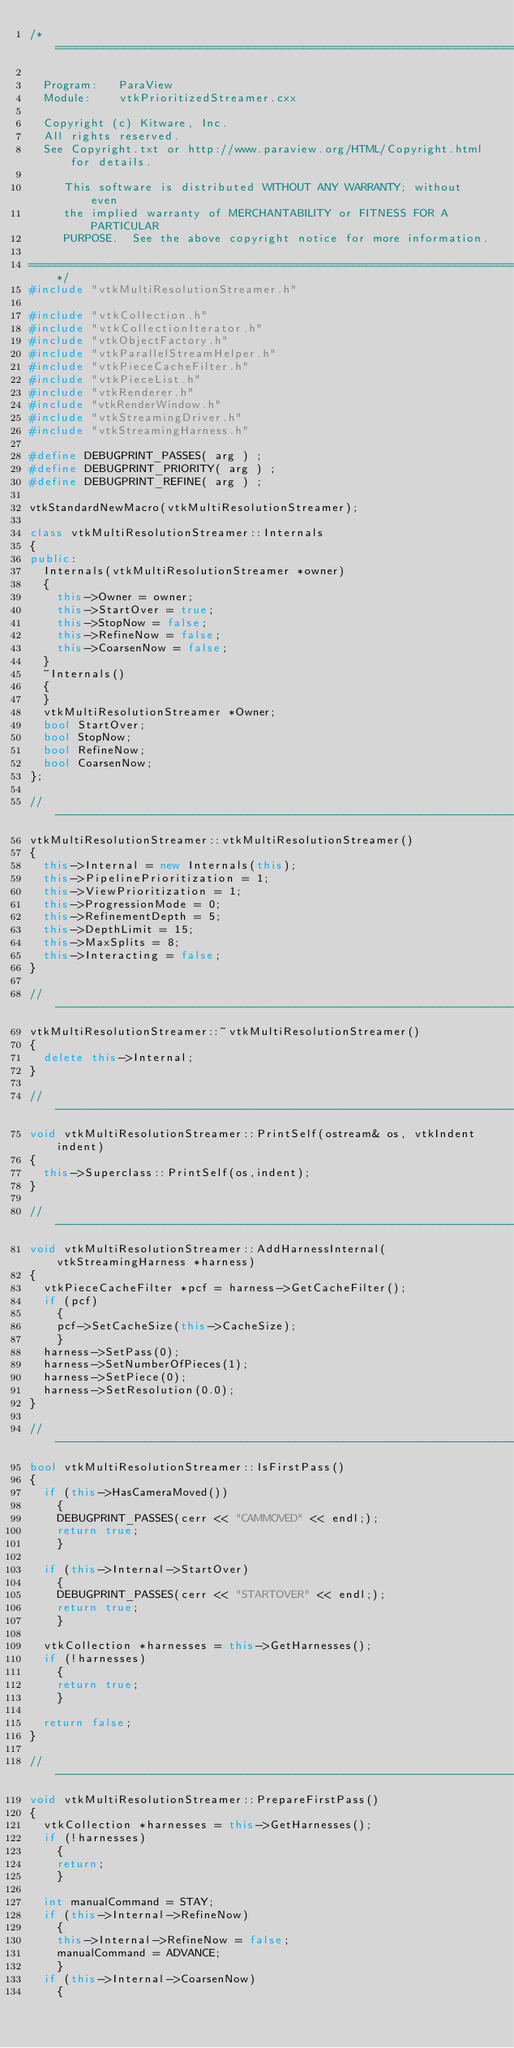<code> <loc_0><loc_0><loc_500><loc_500><_C++_>/*=========================================================================

  Program:   ParaView
  Module:    vtkPrioritizedStreamer.cxx

  Copyright (c) Kitware, Inc.
  All rights reserved.
  See Copyright.txt or http://www.paraview.org/HTML/Copyright.html for details.

     This software is distributed WITHOUT ANY WARRANTY; without even
     the implied warranty of MERCHANTABILITY or FITNESS FOR A PARTICULAR
     PURPOSE.  See the above copyright notice for more information.

=========================================================================*/
#include "vtkMultiResolutionStreamer.h"

#include "vtkCollection.h"
#include "vtkCollectionIterator.h"
#include "vtkObjectFactory.h"
#include "vtkParallelStreamHelper.h"
#include "vtkPieceCacheFilter.h"
#include "vtkPieceList.h"
#include "vtkRenderer.h"
#include "vtkRenderWindow.h"
#include "vtkStreamingDriver.h"
#include "vtkStreamingHarness.h"

#define DEBUGPRINT_PASSES( arg ) ;
#define DEBUGPRINT_PRIORITY( arg ) ;
#define DEBUGPRINT_REFINE( arg ) ;

vtkStandardNewMacro(vtkMultiResolutionStreamer);

class vtkMultiResolutionStreamer::Internals
{
public:
  Internals(vtkMultiResolutionStreamer *owner)
  {
    this->Owner = owner;
    this->StartOver = true;
    this->StopNow = false;
    this->RefineNow = false;
    this->CoarsenNow = false;
  }
  ~Internals()
  {
  }
  vtkMultiResolutionStreamer *Owner;
  bool StartOver;
  bool StopNow;
  bool RefineNow;
  bool CoarsenNow;
};

//----------------------------------------------------------------------------
vtkMultiResolutionStreamer::vtkMultiResolutionStreamer()
{
  this->Internal = new Internals(this);
  this->PipelinePrioritization = 1;
  this->ViewPrioritization = 1;
  this->ProgressionMode = 0;
  this->RefinementDepth = 5;
  this->DepthLimit = 15;
  this->MaxSplits = 8;
  this->Interacting = false;
}

//----------------------------------------------------------------------------
vtkMultiResolutionStreamer::~vtkMultiResolutionStreamer()
{
  delete this->Internal;
}

//----------------------------------------------------------------------------
void vtkMultiResolutionStreamer::PrintSelf(ostream& os, vtkIndent indent)
{
  this->Superclass::PrintSelf(os,indent);
}

//----------------------------------------------------------------------------
void vtkMultiResolutionStreamer::AddHarnessInternal(vtkStreamingHarness *harness)
{
  vtkPieceCacheFilter *pcf = harness->GetCacheFilter();
  if (pcf)
    {
    pcf->SetCacheSize(this->CacheSize);
    }
  harness->SetPass(0);
  harness->SetNumberOfPieces(1);
  harness->SetPiece(0);
  harness->SetResolution(0.0);
}

//----------------------------------------------------------------------------
bool vtkMultiResolutionStreamer::IsFirstPass()
{
  if (this->HasCameraMoved())
    {
    DEBUGPRINT_PASSES(cerr << "CAMMOVED" << endl;);
    return true;
    }

  if (this->Internal->StartOver)
    {
    DEBUGPRINT_PASSES(cerr << "STARTOVER" << endl;);
    return true;
    }

  vtkCollection *harnesses = this->GetHarnesses();
  if (!harnesses)
    {
    return true;
    }

  return false;
}

//----------------------------------------------------------------------------
void vtkMultiResolutionStreamer::PrepareFirstPass()
{
  vtkCollection *harnesses = this->GetHarnesses();
  if (!harnesses)
    {
    return;
    }

  int manualCommand = STAY;
  if (this->Internal->RefineNow)
    {
    this->Internal->RefineNow = false;
    manualCommand = ADVANCE;
    }
  if (this->Internal->CoarsenNow)
    {</code> 